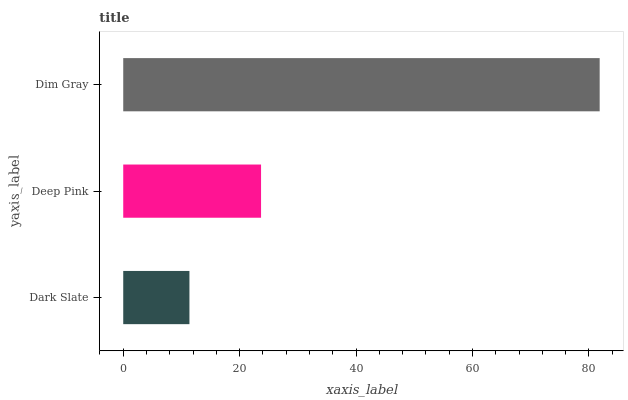Is Dark Slate the minimum?
Answer yes or no. Yes. Is Dim Gray the maximum?
Answer yes or no. Yes. Is Deep Pink the minimum?
Answer yes or no. No. Is Deep Pink the maximum?
Answer yes or no. No. Is Deep Pink greater than Dark Slate?
Answer yes or no. Yes. Is Dark Slate less than Deep Pink?
Answer yes or no. Yes. Is Dark Slate greater than Deep Pink?
Answer yes or no. No. Is Deep Pink less than Dark Slate?
Answer yes or no. No. Is Deep Pink the high median?
Answer yes or no. Yes. Is Deep Pink the low median?
Answer yes or no. Yes. Is Dim Gray the high median?
Answer yes or no. No. Is Dim Gray the low median?
Answer yes or no. No. 